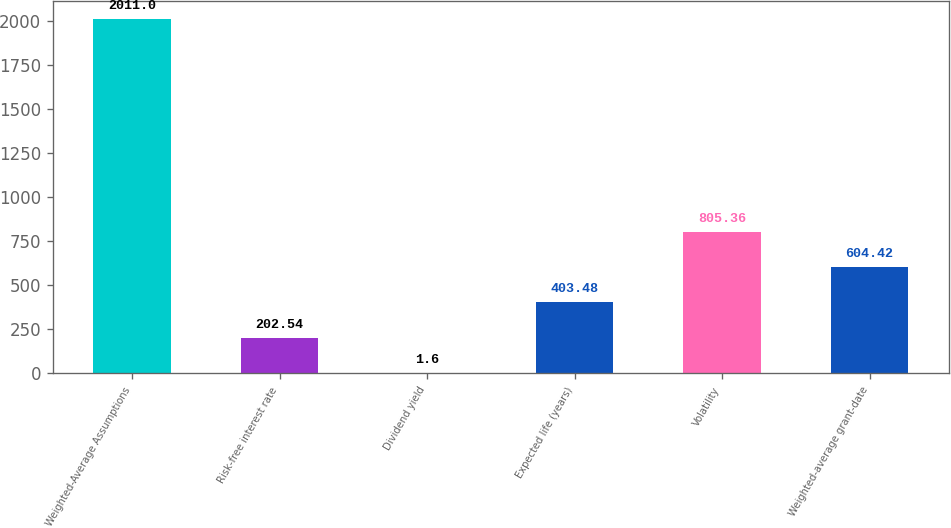Convert chart. <chart><loc_0><loc_0><loc_500><loc_500><bar_chart><fcel>Weighted-Average Assumptions<fcel>Risk-free interest rate<fcel>Dividend yield<fcel>Expected life (years)<fcel>Volatility<fcel>Weighted-average grant-date<nl><fcel>2011<fcel>202.54<fcel>1.6<fcel>403.48<fcel>805.36<fcel>604.42<nl></chart> 